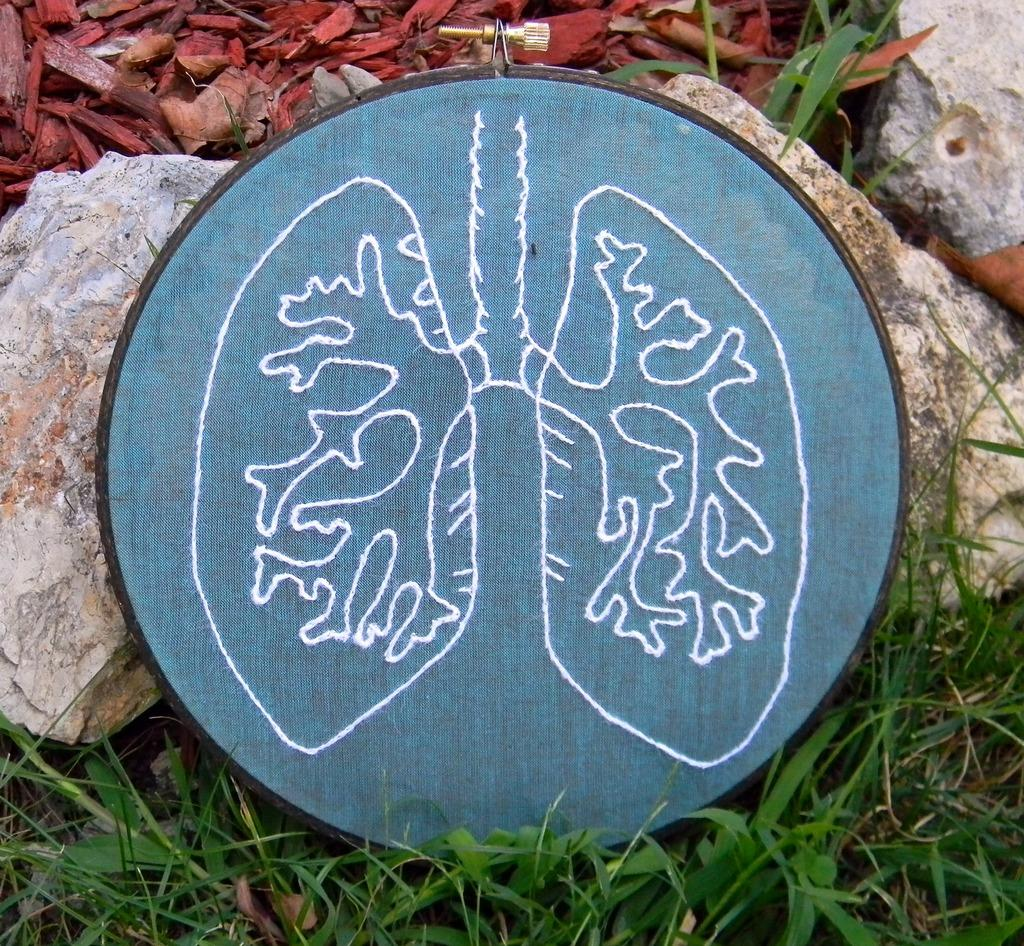What type of work is being done in the image? There is thread work on a ring frame hoop in the image. What can be seen in the background of the image? There are rocks and grass in the background of the image. What material is visible in the image? Sawdust is visible in the image. What type of trousers is the person wearing in the image? There is no person visible in the image, so it is not possible to determine what type of trousers they might be wearing. --- Facts: 1. There is a person holding a book in the image. 2. The person is sitting on a chair. 3. There is a table in the image. 4. The table has a lamp on it. 5. The background of the image is a room. Absurd Topics: parrot, ocean, bicycle Conversation: What is the person in the image holding? The person is holding a book in the image. What is the person's position in the image? The person is sitting on a chair. What furniture is present in the image? There is a table in the image. What is on the table in the image? The table has a lamp on it. What type of setting is depicted in the image? The background of the image is a room. Reasoning: Let's think step by step in order to produce the conversation. We start by identifying the main subject in the image, which is the person holding a book. Then, we describe the person's position and the furniture present in the image. Next, we mention the object on the table, which is a lamp. Finally, we describe the setting of the image, which is a room. Each question is designed to elicit a specific detail about the image that is known from the provided facts. Absurd Question/Answer: Can you see a parrot flying over the ocean in the image? There is no parrot or ocean present in the image; it depicts a person sitting in a room with a book, chair, table, and lamp. 